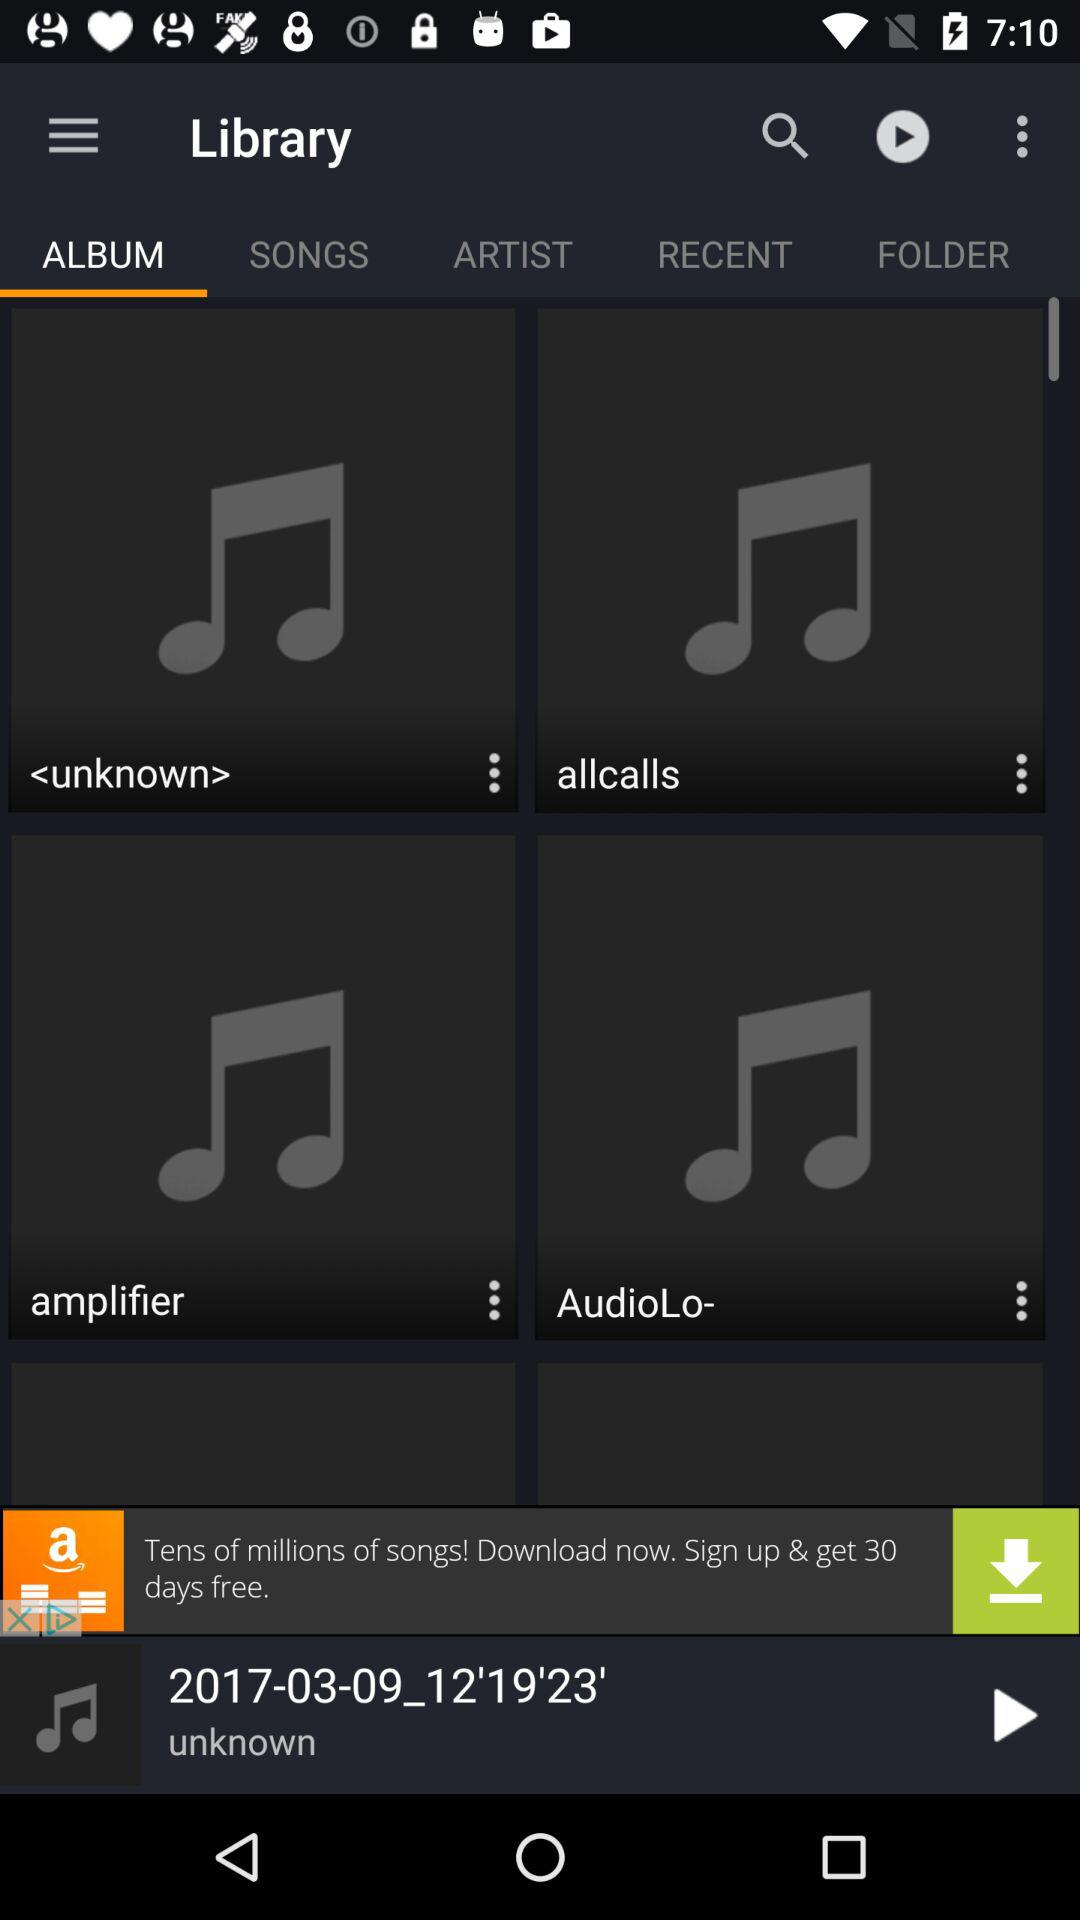What is the name of the song that is currently playing? The name of the song that is currently playing is "2017-03-09_12'19'23'". 